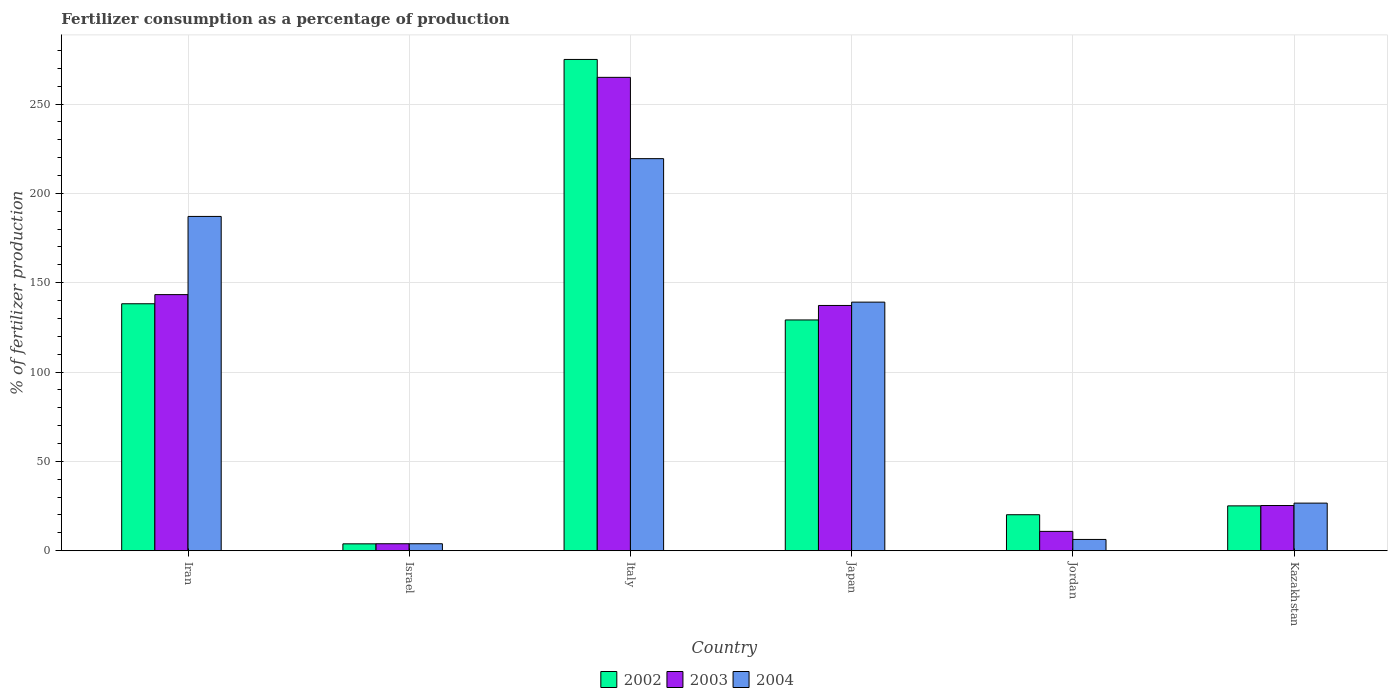How many different coloured bars are there?
Provide a succinct answer. 3. How many groups of bars are there?
Provide a short and direct response. 6. Are the number of bars per tick equal to the number of legend labels?
Give a very brief answer. Yes. How many bars are there on the 5th tick from the left?
Your answer should be compact. 3. How many bars are there on the 2nd tick from the right?
Your answer should be compact. 3. In how many cases, is the number of bars for a given country not equal to the number of legend labels?
Provide a succinct answer. 0. What is the percentage of fertilizers consumed in 2003 in Kazakhstan?
Ensure brevity in your answer.  25.3. Across all countries, what is the maximum percentage of fertilizers consumed in 2002?
Offer a very short reply. 274.97. Across all countries, what is the minimum percentage of fertilizers consumed in 2004?
Keep it short and to the point. 3.9. In which country was the percentage of fertilizers consumed in 2002 minimum?
Offer a very short reply. Israel. What is the total percentage of fertilizers consumed in 2004 in the graph?
Your response must be concise. 582.54. What is the difference between the percentage of fertilizers consumed in 2002 in Japan and that in Jordan?
Keep it short and to the point. 109.02. What is the difference between the percentage of fertilizers consumed in 2003 in Kazakhstan and the percentage of fertilizers consumed in 2002 in Japan?
Your response must be concise. -103.86. What is the average percentage of fertilizers consumed in 2002 per country?
Your answer should be compact. 98.58. What is the difference between the percentage of fertilizers consumed of/in 2002 and percentage of fertilizers consumed of/in 2003 in Japan?
Keep it short and to the point. -8.11. In how many countries, is the percentage of fertilizers consumed in 2004 greater than 90 %?
Keep it short and to the point. 3. What is the ratio of the percentage of fertilizers consumed in 2002 in Iran to that in Italy?
Make the answer very short. 0.5. What is the difference between the highest and the second highest percentage of fertilizers consumed in 2003?
Give a very brief answer. 127.67. What is the difference between the highest and the lowest percentage of fertilizers consumed in 2004?
Keep it short and to the point. 215.54. In how many countries, is the percentage of fertilizers consumed in 2004 greater than the average percentage of fertilizers consumed in 2004 taken over all countries?
Keep it short and to the point. 3. Is the sum of the percentage of fertilizers consumed in 2003 in Israel and Italy greater than the maximum percentage of fertilizers consumed in 2002 across all countries?
Offer a very short reply. No. Is it the case that in every country, the sum of the percentage of fertilizers consumed in 2004 and percentage of fertilizers consumed in 2003 is greater than the percentage of fertilizers consumed in 2002?
Offer a very short reply. No. How many bars are there?
Offer a very short reply. 18. How many countries are there in the graph?
Provide a short and direct response. 6. What is the difference between two consecutive major ticks on the Y-axis?
Keep it short and to the point. 50. Are the values on the major ticks of Y-axis written in scientific E-notation?
Make the answer very short. No. Where does the legend appear in the graph?
Your response must be concise. Bottom center. How many legend labels are there?
Provide a succinct answer. 3. What is the title of the graph?
Your answer should be very brief. Fertilizer consumption as a percentage of production. What is the label or title of the X-axis?
Offer a terse response. Country. What is the label or title of the Y-axis?
Offer a very short reply. % of fertilizer production. What is the % of fertilizer production of 2002 in Iran?
Ensure brevity in your answer.  138.23. What is the % of fertilizer production of 2003 in Iran?
Ensure brevity in your answer.  143.34. What is the % of fertilizer production of 2004 in Iran?
Offer a very short reply. 187.1. What is the % of fertilizer production in 2002 in Israel?
Make the answer very short. 3.85. What is the % of fertilizer production of 2003 in Israel?
Offer a very short reply. 3.9. What is the % of fertilizer production of 2004 in Israel?
Offer a terse response. 3.9. What is the % of fertilizer production of 2002 in Italy?
Make the answer very short. 274.97. What is the % of fertilizer production of 2003 in Italy?
Offer a terse response. 264.94. What is the % of fertilizer production in 2004 in Italy?
Provide a succinct answer. 219.45. What is the % of fertilizer production of 2002 in Japan?
Provide a short and direct response. 129.16. What is the % of fertilizer production of 2003 in Japan?
Offer a very short reply. 137.27. What is the % of fertilizer production of 2004 in Japan?
Provide a succinct answer. 139.13. What is the % of fertilizer production in 2002 in Jordan?
Offer a very short reply. 20.14. What is the % of fertilizer production in 2003 in Jordan?
Your answer should be very brief. 10.83. What is the % of fertilizer production in 2004 in Jordan?
Provide a succinct answer. 6.31. What is the % of fertilizer production in 2002 in Kazakhstan?
Ensure brevity in your answer.  25.11. What is the % of fertilizer production of 2003 in Kazakhstan?
Your answer should be very brief. 25.3. What is the % of fertilizer production of 2004 in Kazakhstan?
Make the answer very short. 26.65. Across all countries, what is the maximum % of fertilizer production of 2002?
Offer a terse response. 274.97. Across all countries, what is the maximum % of fertilizer production of 2003?
Provide a succinct answer. 264.94. Across all countries, what is the maximum % of fertilizer production of 2004?
Your response must be concise. 219.45. Across all countries, what is the minimum % of fertilizer production of 2002?
Give a very brief answer. 3.85. Across all countries, what is the minimum % of fertilizer production of 2003?
Your answer should be very brief. 3.9. Across all countries, what is the minimum % of fertilizer production of 2004?
Your answer should be very brief. 3.9. What is the total % of fertilizer production of 2002 in the graph?
Your response must be concise. 591.46. What is the total % of fertilizer production of 2003 in the graph?
Your answer should be compact. 585.57. What is the total % of fertilizer production in 2004 in the graph?
Your answer should be compact. 582.54. What is the difference between the % of fertilizer production of 2002 in Iran and that in Israel?
Offer a terse response. 134.38. What is the difference between the % of fertilizer production of 2003 in Iran and that in Israel?
Make the answer very short. 139.43. What is the difference between the % of fertilizer production of 2004 in Iran and that in Israel?
Keep it short and to the point. 183.2. What is the difference between the % of fertilizer production of 2002 in Iran and that in Italy?
Offer a terse response. -136.74. What is the difference between the % of fertilizer production in 2003 in Iran and that in Italy?
Your answer should be very brief. -121.6. What is the difference between the % of fertilizer production of 2004 in Iran and that in Italy?
Keep it short and to the point. -32.34. What is the difference between the % of fertilizer production in 2002 in Iran and that in Japan?
Keep it short and to the point. 9.07. What is the difference between the % of fertilizer production in 2003 in Iran and that in Japan?
Keep it short and to the point. 6.07. What is the difference between the % of fertilizer production of 2004 in Iran and that in Japan?
Your answer should be compact. 47.97. What is the difference between the % of fertilizer production in 2002 in Iran and that in Jordan?
Give a very brief answer. 118.09. What is the difference between the % of fertilizer production in 2003 in Iran and that in Jordan?
Give a very brief answer. 132.51. What is the difference between the % of fertilizer production in 2004 in Iran and that in Jordan?
Provide a short and direct response. 180.8. What is the difference between the % of fertilizer production in 2002 in Iran and that in Kazakhstan?
Keep it short and to the point. 113.12. What is the difference between the % of fertilizer production in 2003 in Iran and that in Kazakhstan?
Make the answer very short. 118.04. What is the difference between the % of fertilizer production of 2004 in Iran and that in Kazakhstan?
Offer a very short reply. 160.46. What is the difference between the % of fertilizer production in 2002 in Israel and that in Italy?
Offer a terse response. -271.12. What is the difference between the % of fertilizer production of 2003 in Israel and that in Italy?
Give a very brief answer. -261.04. What is the difference between the % of fertilizer production of 2004 in Israel and that in Italy?
Ensure brevity in your answer.  -215.54. What is the difference between the % of fertilizer production of 2002 in Israel and that in Japan?
Make the answer very short. -125.31. What is the difference between the % of fertilizer production of 2003 in Israel and that in Japan?
Provide a short and direct response. -133.36. What is the difference between the % of fertilizer production of 2004 in Israel and that in Japan?
Ensure brevity in your answer.  -135.23. What is the difference between the % of fertilizer production in 2002 in Israel and that in Jordan?
Provide a short and direct response. -16.29. What is the difference between the % of fertilizer production of 2003 in Israel and that in Jordan?
Offer a terse response. -6.92. What is the difference between the % of fertilizer production of 2004 in Israel and that in Jordan?
Offer a terse response. -2.41. What is the difference between the % of fertilizer production of 2002 in Israel and that in Kazakhstan?
Your answer should be very brief. -21.25. What is the difference between the % of fertilizer production of 2003 in Israel and that in Kazakhstan?
Your response must be concise. -21.39. What is the difference between the % of fertilizer production of 2004 in Israel and that in Kazakhstan?
Offer a very short reply. -22.74. What is the difference between the % of fertilizer production in 2002 in Italy and that in Japan?
Offer a very short reply. 145.81. What is the difference between the % of fertilizer production of 2003 in Italy and that in Japan?
Give a very brief answer. 127.67. What is the difference between the % of fertilizer production of 2004 in Italy and that in Japan?
Your answer should be compact. 80.32. What is the difference between the % of fertilizer production in 2002 in Italy and that in Jordan?
Offer a very short reply. 254.83. What is the difference between the % of fertilizer production of 2003 in Italy and that in Jordan?
Your response must be concise. 254.12. What is the difference between the % of fertilizer production in 2004 in Italy and that in Jordan?
Provide a short and direct response. 213.14. What is the difference between the % of fertilizer production in 2002 in Italy and that in Kazakhstan?
Your answer should be very brief. 249.86. What is the difference between the % of fertilizer production in 2003 in Italy and that in Kazakhstan?
Ensure brevity in your answer.  239.64. What is the difference between the % of fertilizer production of 2004 in Italy and that in Kazakhstan?
Ensure brevity in your answer.  192.8. What is the difference between the % of fertilizer production of 2002 in Japan and that in Jordan?
Keep it short and to the point. 109.02. What is the difference between the % of fertilizer production in 2003 in Japan and that in Jordan?
Make the answer very short. 126.44. What is the difference between the % of fertilizer production of 2004 in Japan and that in Jordan?
Give a very brief answer. 132.82. What is the difference between the % of fertilizer production of 2002 in Japan and that in Kazakhstan?
Your response must be concise. 104.05. What is the difference between the % of fertilizer production in 2003 in Japan and that in Kazakhstan?
Provide a short and direct response. 111.97. What is the difference between the % of fertilizer production of 2004 in Japan and that in Kazakhstan?
Make the answer very short. 112.49. What is the difference between the % of fertilizer production in 2002 in Jordan and that in Kazakhstan?
Offer a very short reply. -4.96. What is the difference between the % of fertilizer production of 2003 in Jordan and that in Kazakhstan?
Keep it short and to the point. -14.47. What is the difference between the % of fertilizer production in 2004 in Jordan and that in Kazakhstan?
Provide a short and direct response. -20.34. What is the difference between the % of fertilizer production in 2002 in Iran and the % of fertilizer production in 2003 in Israel?
Offer a terse response. 134.32. What is the difference between the % of fertilizer production in 2002 in Iran and the % of fertilizer production in 2004 in Israel?
Ensure brevity in your answer.  134.32. What is the difference between the % of fertilizer production in 2003 in Iran and the % of fertilizer production in 2004 in Israel?
Offer a terse response. 139.43. What is the difference between the % of fertilizer production in 2002 in Iran and the % of fertilizer production in 2003 in Italy?
Offer a very short reply. -126.71. What is the difference between the % of fertilizer production of 2002 in Iran and the % of fertilizer production of 2004 in Italy?
Provide a succinct answer. -81.22. What is the difference between the % of fertilizer production of 2003 in Iran and the % of fertilizer production of 2004 in Italy?
Keep it short and to the point. -76.11. What is the difference between the % of fertilizer production of 2002 in Iran and the % of fertilizer production of 2003 in Japan?
Provide a short and direct response. 0.96. What is the difference between the % of fertilizer production in 2002 in Iran and the % of fertilizer production in 2004 in Japan?
Provide a succinct answer. -0.9. What is the difference between the % of fertilizer production in 2003 in Iran and the % of fertilizer production in 2004 in Japan?
Ensure brevity in your answer.  4.21. What is the difference between the % of fertilizer production of 2002 in Iran and the % of fertilizer production of 2003 in Jordan?
Keep it short and to the point. 127.4. What is the difference between the % of fertilizer production of 2002 in Iran and the % of fertilizer production of 2004 in Jordan?
Your response must be concise. 131.92. What is the difference between the % of fertilizer production in 2003 in Iran and the % of fertilizer production in 2004 in Jordan?
Offer a terse response. 137.03. What is the difference between the % of fertilizer production in 2002 in Iran and the % of fertilizer production in 2003 in Kazakhstan?
Your answer should be very brief. 112.93. What is the difference between the % of fertilizer production in 2002 in Iran and the % of fertilizer production in 2004 in Kazakhstan?
Ensure brevity in your answer.  111.58. What is the difference between the % of fertilizer production in 2003 in Iran and the % of fertilizer production in 2004 in Kazakhstan?
Your answer should be compact. 116.69. What is the difference between the % of fertilizer production in 2002 in Israel and the % of fertilizer production in 2003 in Italy?
Make the answer very short. -261.09. What is the difference between the % of fertilizer production of 2002 in Israel and the % of fertilizer production of 2004 in Italy?
Offer a very short reply. -215.59. What is the difference between the % of fertilizer production in 2003 in Israel and the % of fertilizer production in 2004 in Italy?
Offer a very short reply. -215.54. What is the difference between the % of fertilizer production of 2002 in Israel and the % of fertilizer production of 2003 in Japan?
Keep it short and to the point. -133.41. What is the difference between the % of fertilizer production in 2002 in Israel and the % of fertilizer production in 2004 in Japan?
Offer a terse response. -135.28. What is the difference between the % of fertilizer production of 2003 in Israel and the % of fertilizer production of 2004 in Japan?
Make the answer very short. -135.23. What is the difference between the % of fertilizer production of 2002 in Israel and the % of fertilizer production of 2003 in Jordan?
Your answer should be compact. -6.97. What is the difference between the % of fertilizer production of 2002 in Israel and the % of fertilizer production of 2004 in Jordan?
Make the answer very short. -2.46. What is the difference between the % of fertilizer production in 2003 in Israel and the % of fertilizer production in 2004 in Jordan?
Make the answer very short. -2.41. What is the difference between the % of fertilizer production of 2002 in Israel and the % of fertilizer production of 2003 in Kazakhstan?
Ensure brevity in your answer.  -21.45. What is the difference between the % of fertilizer production in 2002 in Israel and the % of fertilizer production in 2004 in Kazakhstan?
Give a very brief answer. -22.79. What is the difference between the % of fertilizer production in 2003 in Israel and the % of fertilizer production in 2004 in Kazakhstan?
Your answer should be very brief. -22.74. What is the difference between the % of fertilizer production of 2002 in Italy and the % of fertilizer production of 2003 in Japan?
Give a very brief answer. 137.7. What is the difference between the % of fertilizer production of 2002 in Italy and the % of fertilizer production of 2004 in Japan?
Provide a short and direct response. 135.84. What is the difference between the % of fertilizer production of 2003 in Italy and the % of fertilizer production of 2004 in Japan?
Provide a succinct answer. 125.81. What is the difference between the % of fertilizer production in 2002 in Italy and the % of fertilizer production in 2003 in Jordan?
Offer a very short reply. 264.14. What is the difference between the % of fertilizer production of 2002 in Italy and the % of fertilizer production of 2004 in Jordan?
Provide a succinct answer. 268.66. What is the difference between the % of fertilizer production in 2003 in Italy and the % of fertilizer production in 2004 in Jordan?
Your answer should be very brief. 258.63. What is the difference between the % of fertilizer production in 2002 in Italy and the % of fertilizer production in 2003 in Kazakhstan?
Offer a very short reply. 249.67. What is the difference between the % of fertilizer production in 2002 in Italy and the % of fertilizer production in 2004 in Kazakhstan?
Give a very brief answer. 248.32. What is the difference between the % of fertilizer production in 2003 in Italy and the % of fertilizer production in 2004 in Kazakhstan?
Offer a terse response. 238.3. What is the difference between the % of fertilizer production in 2002 in Japan and the % of fertilizer production in 2003 in Jordan?
Offer a terse response. 118.33. What is the difference between the % of fertilizer production of 2002 in Japan and the % of fertilizer production of 2004 in Jordan?
Provide a succinct answer. 122.85. What is the difference between the % of fertilizer production of 2003 in Japan and the % of fertilizer production of 2004 in Jordan?
Ensure brevity in your answer.  130.96. What is the difference between the % of fertilizer production of 2002 in Japan and the % of fertilizer production of 2003 in Kazakhstan?
Provide a short and direct response. 103.86. What is the difference between the % of fertilizer production of 2002 in Japan and the % of fertilizer production of 2004 in Kazakhstan?
Offer a terse response. 102.51. What is the difference between the % of fertilizer production in 2003 in Japan and the % of fertilizer production in 2004 in Kazakhstan?
Offer a very short reply. 110.62. What is the difference between the % of fertilizer production of 2002 in Jordan and the % of fertilizer production of 2003 in Kazakhstan?
Offer a terse response. -5.16. What is the difference between the % of fertilizer production in 2002 in Jordan and the % of fertilizer production in 2004 in Kazakhstan?
Provide a short and direct response. -6.5. What is the difference between the % of fertilizer production of 2003 in Jordan and the % of fertilizer production of 2004 in Kazakhstan?
Provide a succinct answer. -15.82. What is the average % of fertilizer production in 2002 per country?
Provide a succinct answer. 98.58. What is the average % of fertilizer production of 2003 per country?
Ensure brevity in your answer.  97.6. What is the average % of fertilizer production of 2004 per country?
Ensure brevity in your answer.  97.09. What is the difference between the % of fertilizer production in 2002 and % of fertilizer production in 2003 in Iran?
Offer a very short reply. -5.11. What is the difference between the % of fertilizer production of 2002 and % of fertilizer production of 2004 in Iran?
Make the answer very short. -48.88. What is the difference between the % of fertilizer production of 2003 and % of fertilizer production of 2004 in Iran?
Give a very brief answer. -43.77. What is the difference between the % of fertilizer production in 2002 and % of fertilizer production in 2003 in Israel?
Provide a succinct answer. -0.05. What is the difference between the % of fertilizer production in 2002 and % of fertilizer production in 2004 in Israel?
Provide a short and direct response. -0.05. What is the difference between the % of fertilizer production of 2003 and % of fertilizer production of 2004 in Israel?
Your response must be concise. -0. What is the difference between the % of fertilizer production of 2002 and % of fertilizer production of 2003 in Italy?
Offer a very short reply. 10.03. What is the difference between the % of fertilizer production in 2002 and % of fertilizer production in 2004 in Italy?
Provide a short and direct response. 55.52. What is the difference between the % of fertilizer production of 2003 and % of fertilizer production of 2004 in Italy?
Ensure brevity in your answer.  45.5. What is the difference between the % of fertilizer production of 2002 and % of fertilizer production of 2003 in Japan?
Give a very brief answer. -8.11. What is the difference between the % of fertilizer production in 2002 and % of fertilizer production in 2004 in Japan?
Keep it short and to the point. -9.97. What is the difference between the % of fertilizer production in 2003 and % of fertilizer production in 2004 in Japan?
Your response must be concise. -1.86. What is the difference between the % of fertilizer production of 2002 and % of fertilizer production of 2003 in Jordan?
Give a very brief answer. 9.32. What is the difference between the % of fertilizer production of 2002 and % of fertilizer production of 2004 in Jordan?
Offer a very short reply. 13.83. What is the difference between the % of fertilizer production in 2003 and % of fertilizer production in 2004 in Jordan?
Ensure brevity in your answer.  4.52. What is the difference between the % of fertilizer production in 2002 and % of fertilizer production in 2003 in Kazakhstan?
Make the answer very short. -0.19. What is the difference between the % of fertilizer production in 2002 and % of fertilizer production in 2004 in Kazakhstan?
Make the answer very short. -1.54. What is the difference between the % of fertilizer production of 2003 and % of fertilizer production of 2004 in Kazakhstan?
Your response must be concise. -1.35. What is the ratio of the % of fertilizer production in 2002 in Iran to that in Israel?
Make the answer very short. 35.88. What is the ratio of the % of fertilizer production of 2003 in Iran to that in Israel?
Offer a terse response. 36.72. What is the ratio of the % of fertilizer production in 2004 in Iran to that in Israel?
Offer a very short reply. 47.92. What is the ratio of the % of fertilizer production in 2002 in Iran to that in Italy?
Offer a terse response. 0.5. What is the ratio of the % of fertilizer production of 2003 in Iran to that in Italy?
Ensure brevity in your answer.  0.54. What is the ratio of the % of fertilizer production of 2004 in Iran to that in Italy?
Ensure brevity in your answer.  0.85. What is the ratio of the % of fertilizer production of 2002 in Iran to that in Japan?
Make the answer very short. 1.07. What is the ratio of the % of fertilizer production in 2003 in Iran to that in Japan?
Offer a very short reply. 1.04. What is the ratio of the % of fertilizer production of 2004 in Iran to that in Japan?
Offer a terse response. 1.34. What is the ratio of the % of fertilizer production in 2002 in Iran to that in Jordan?
Provide a succinct answer. 6.86. What is the ratio of the % of fertilizer production of 2003 in Iran to that in Jordan?
Offer a terse response. 13.24. What is the ratio of the % of fertilizer production of 2004 in Iran to that in Jordan?
Give a very brief answer. 29.65. What is the ratio of the % of fertilizer production in 2002 in Iran to that in Kazakhstan?
Your response must be concise. 5.51. What is the ratio of the % of fertilizer production in 2003 in Iran to that in Kazakhstan?
Your answer should be compact. 5.67. What is the ratio of the % of fertilizer production in 2004 in Iran to that in Kazakhstan?
Provide a succinct answer. 7.02. What is the ratio of the % of fertilizer production of 2002 in Israel to that in Italy?
Offer a terse response. 0.01. What is the ratio of the % of fertilizer production in 2003 in Israel to that in Italy?
Provide a succinct answer. 0.01. What is the ratio of the % of fertilizer production of 2004 in Israel to that in Italy?
Provide a short and direct response. 0.02. What is the ratio of the % of fertilizer production of 2002 in Israel to that in Japan?
Your answer should be compact. 0.03. What is the ratio of the % of fertilizer production in 2003 in Israel to that in Japan?
Ensure brevity in your answer.  0.03. What is the ratio of the % of fertilizer production of 2004 in Israel to that in Japan?
Offer a terse response. 0.03. What is the ratio of the % of fertilizer production of 2002 in Israel to that in Jordan?
Your answer should be very brief. 0.19. What is the ratio of the % of fertilizer production of 2003 in Israel to that in Jordan?
Your response must be concise. 0.36. What is the ratio of the % of fertilizer production of 2004 in Israel to that in Jordan?
Your response must be concise. 0.62. What is the ratio of the % of fertilizer production in 2002 in Israel to that in Kazakhstan?
Provide a short and direct response. 0.15. What is the ratio of the % of fertilizer production of 2003 in Israel to that in Kazakhstan?
Ensure brevity in your answer.  0.15. What is the ratio of the % of fertilizer production in 2004 in Israel to that in Kazakhstan?
Give a very brief answer. 0.15. What is the ratio of the % of fertilizer production of 2002 in Italy to that in Japan?
Make the answer very short. 2.13. What is the ratio of the % of fertilizer production in 2003 in Italy to that in Japan?
Your answer should be compact. 1.93. What is the ratio of the % of fertilizer production in 2004 in Italy to that in Japan?
Ensure brevity in your answer.  1.58. What is the ratio of the % of fertilizer production of 2002 in Italy to that in Jordan?
Provide a succinct answer. 13.65. What is the ratio of the % of fertilizer production in 2003 in Italy to that in Jordan?
Ensure brevity in your answer.  24.47. What is the ratio of the % of fertilizer production of 2004 in Italy to that in Jordan?
Give a very brief answer. 34.78. What is the ratio of the % of fertilizer production of 2002 in Italy to that in Kazakhstan?
Provide a succinct answer. 10.95. What is the ratio of the % of fertilizer production of 2003 in Italy to that in Kazakhstan?
Your answer should be compact. 10.47. What is the ratio of the % of fertilizer production of 2004 in Italy to that in Kazakhstan?
Make the answer very short. 8.24. What is the ratio of the % of fertilizer production in 2002 in Japan to that in Jordan?
Offer a very short reply. 6.41. What is the ratio of the % of fertilizer production of 2003 in Japan to that in Jordan?
Your answer should be very brief. 12.68. What is the ratio of the % of fertilizer production of 2004 in Japan to that in Jordan?
Provide a succinct answer. 22.05. What is the ratio of the % of fertilizer production in 2002 in Japan to that in Kazakhstan?
Your answer should be very brief. 5.14. What is the ratio of the % of fertilizer production in 2003 in Japan to that in Kazakhstan?
Provide a succinct answer. 5.43. What is the ratio of the % of fertilizer production in 2004 in Japan to that in Kazakhstan?
Provide a succinct answer. 5.22. What is the ratio of the % of fertilizer production in 2002 in Jordan to that in Kazakhstan?
Ensure brevity in your answer.  0.8. What is the ratio of the % of fertilizer production of 2003 in Jordan to that in Kazakhstan?
Keep it short and to the point. 0.43. What is the ratio of the % of fertilizer production of 2004 in Jordan to that in Kazakhstan?
Your answer should be very brief. 0.24. What is the difference between the highest and the second highest % of fertilizer production of 2002?
Provide a short and direct response. 136.74. What is the difference between the highest and the second highest % of fertilizer production of 2003?
Offer a terse response. 121.6. What is the difference between the highest and the second highest % of fertilizer production of 2004?
Provide a short and direct response. 32.34. What is the difference between the highest and the lowest % of fertilizer production in 2002?
Make the answer very short. 271.12. What is the difference between the highest and the lowest % of fertilizer production of 2003?
Your answer should be very brief. 261.04. What is the difference between the highest and the lowest % of fertilizer production of 2004?
Provide a succinct answer. 215.54. 